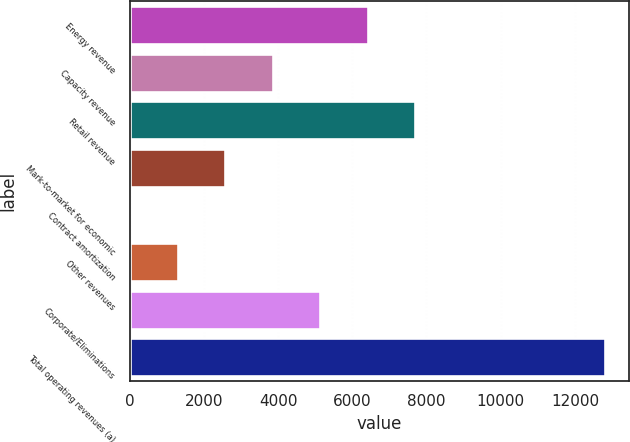<chart> <loc_0><loc_0><loc_500><loc_500><bar_chart><fcel>Energy revenue<fcel>Capacity revenue<fcel>Retail revenue<fcel>Mark-to-market for economic<fcel>Contract amortization<fcel>Other revenues<fcel>Corporate/Eliminations<fcel>Total operating revenues (a)<nl><fcel>6411<fcel>3851.4<fcel>7690.8<fcel>2571.6<fcel>12<fcel>1291.8<fcel>5131.2<fcel>12810<nl></chart> 